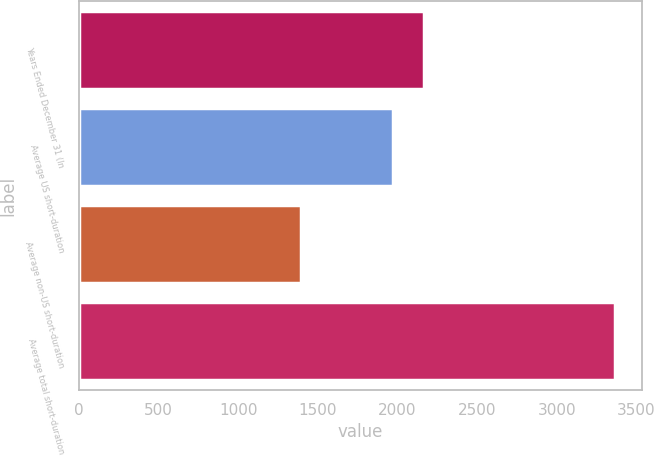Convert chart to OTSL. <chart><loc_0><loc_0><loc_500><loc_500><bar_chart><fcel>Years Ended December 31 (In<fcel>Average US short-duration<fcel>Average non-US short-duration<fcel>Average total short-duration<nl><fcel>2169.2<fcel>1972<fcel>1393<fcel>3365<nl></chart> 